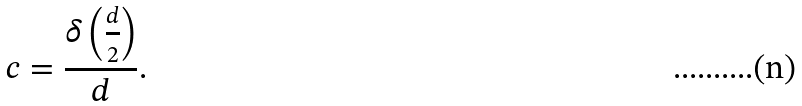<formula> <loc_0><loc_0><loc_500><loc_500>c = \frac { \delta \left ( \frac { d } { 2 } \right ) } { d } .</formula> 